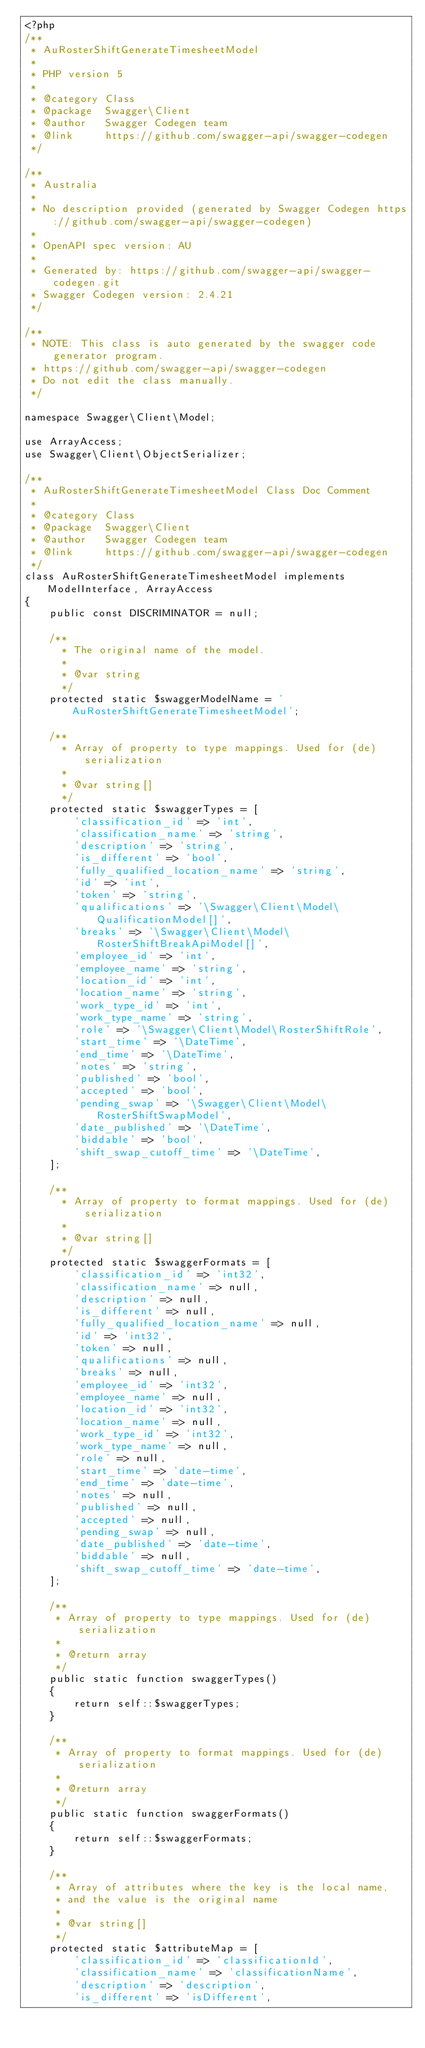<code> <loc_0><loc_0><loc_500><loc_500><_PHP_><?php
/**
 * AuRosterShiftGenerateTimesheetModel
 *
 * PHP version 5
 *
 * @category Class
 * @package  Swagger\Client
 * @author   Swagger Codegen team
 * @link     https://github.com/swagger-api/swagger-codegen
 */

/**
 * Australia
 *
 * No description provided (generated by Swagger Codegen https://github.com/swagger-api/swagger-codegen)
 *
 * OpenAPI spec version: AU
 *
 * Generated by: https://github.com/swagger-api/swagger-codegen.git
 * Swagger Codegen version: 2.4.21
 */

/**
 * NOTE: This class is auto generated by the swagger code generator program.
 * https://github.com/swagger-api/swagger-codegen
 * Do not edit the class manually.
 */

namespace Swagger\Client\Model;

use ArrayAccess;
use Swagger\Client\ObjectSerializer;

/**
 * AuRosterShiftGenerateTimesheetModel Class Doc Comment
 *
 * @category Class
 * @package  Swagger\Client
 * @author   Swagger Codegen team
 * @link     https://github.com/swagger-api/swagger-codegen
 */
class AuRosterShiftGenerateTimesheetModel implements ModelInterface, ArrayAccess
{
    public const DISCRIMINATOR = null;

    /**
      * The original name of the model.
      *
      * @var string
      */
    protected static $swaggerModelName = 'AuRosterShiftGenerateTimesheetModel';

    /**
      * Array of property to type mappings. Used for (de)serialization
      *
      * @var string[]
      */
    protected static $swaggerTypes = [
        'classification_id' => 'int',
        'classification_name' => 'string',
        'description' => 'string',
        'is_different' => 'bool',
        'fully_qualified_location_name' => 'string',
        'id' => 'int',
        'token' => 'string',
        'qualifications' => '\Swagger\Client\Model\QualificationModel[]',
        'breaks' => '\Swagger\Client\Model\RosterShiftBreakApiModel[]',
        'employee_id' => 'int',
        'employee_name' => 'string',
        'location_id' => 'int',
        'location_name' => 'string',
        'work_type_id' => 'int',
        'work_type_name' => 'string',
        'role' => '\Swagger\Client\Model\RosterShiftRole',
        'start_time' => '\DateTime',
        'end_time' => '\DateTime',
        'notes' => 'string',
        'published' => 'bool',
        'accepted' => 'bool',
        'pending_swap' => '\Swagger\Client\Model\RosterShiftSwapModel',
        'date_published' => '\DateTime',
        'biddable' => 'bool',
        'shift_swap_cutoff_time' => '\DateTime',
    ];

    /**
      * Array of property to format mappings. Used for (de)serialization
      *
      * @var string[]
      */
    protected static $swaggerFormats = [
        'classification_id' => 'int32',
        'classification_name' => null,
        'description' => null,
        'is_different' => null,
        'fully_qualified_location_name' => null,
        'id' => 'int32',
        'token' => null,
        'qualifications' => null,
        'breaks' => null,
        'employee_id' => 'int32',
        'employee_name' => null,
        'location_id' => 'int32',
        'location_name' => null,
        'work_type_id' => 'int32',
        'work_type_name' => null,
        'role' => null,
        'start_time' => 'date-time',
        'end_time' => 'date-time',
        'notes' => null,
        'published' => null,
        'accepted' => null,
        'pending_swap' => null,
        'date_published' => 'date-time',
        'biddable' => null,
        'shift_swap_cutoff_time' => 'date-time',
    ];

    /**
     * Array of property to type mappings. Used for (de)serialization
     *
     * @return array
     */
    public static function swaggerTypes()
    {
        return self::$swaggerTypes;
    }

    /**
     * Array of property to format mappings. Used for (de)serialization
     *
     * @return array
     */
    public static function swaggerFormats()
    {
        return self::$swaggerFormats;
    }

    /**
     * Array of attributes where the key is the local name,
     * and the value is the original name
     *
     * @var string[]
     */
    protected static $attributeMap = [
        'classification_id' => 'classificationId',
        'classification_name' => 'classificationName',
        'description' => 'description',
        'is_different' => 'isDifferent',</code> 